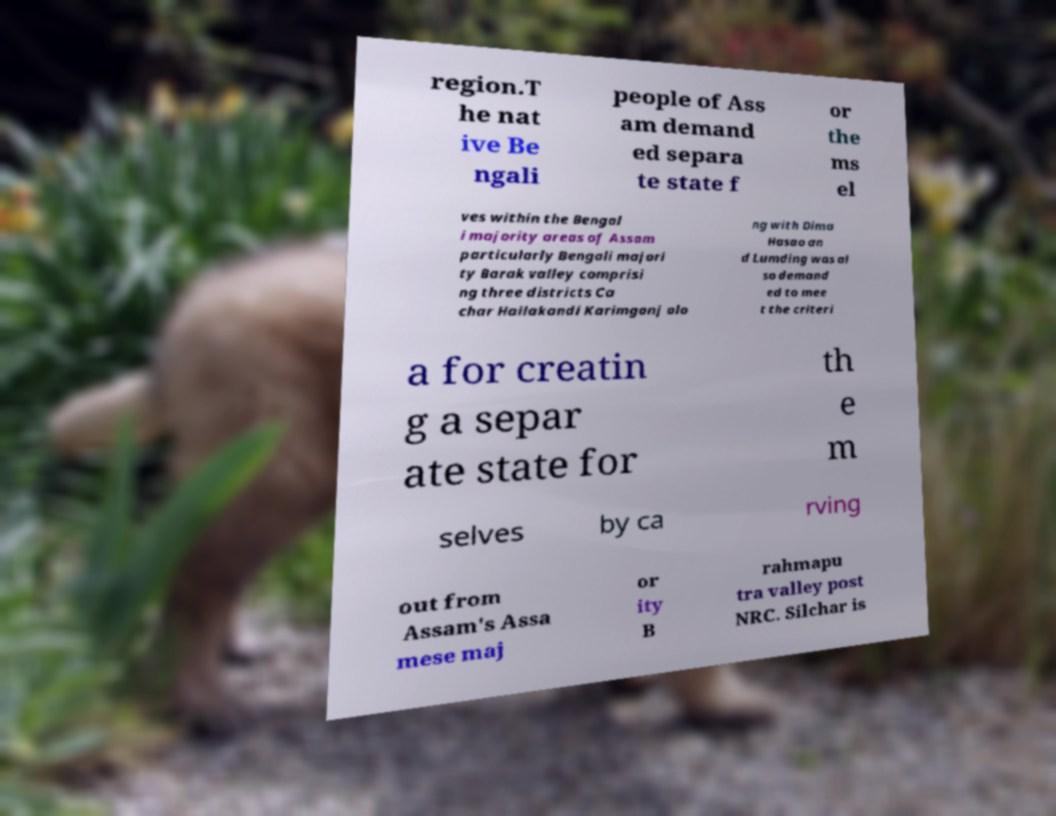I need the written content from this picture converted into text. Can you do that? region.T he nat ive Be ngali people of Ass am demand ed separa te state f or the ms el ves within the Bengal i majority areas of Assam particularly Bengali majori ty Barak valley comprisi ng three districts Ca char Hailakandi Karimganj alo ng with Dima Hasao an d Lumding was al so demand ed to mee t the criteri a for creatin g a separ ate state for th e m selves by ca rving out from Assam's Assa mese maj or ity B rahmapu tra valley post NRC. Silchar is 